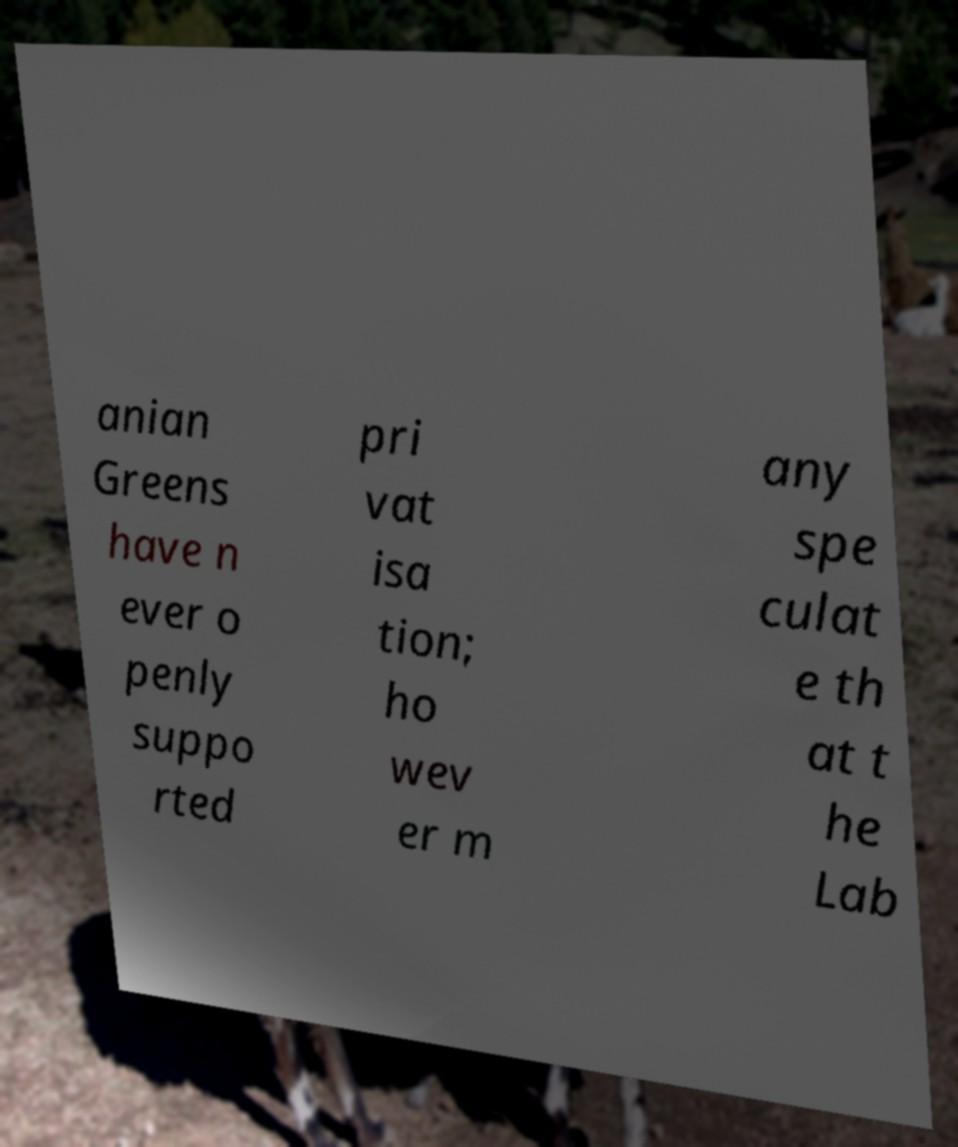For documentation purposes, I need the text within this image transcribed. Could you provide that? anian Greens have n ever o penly suppo rted pri vat isa tion; ho wev er m any spe culat e th at t he Lab 